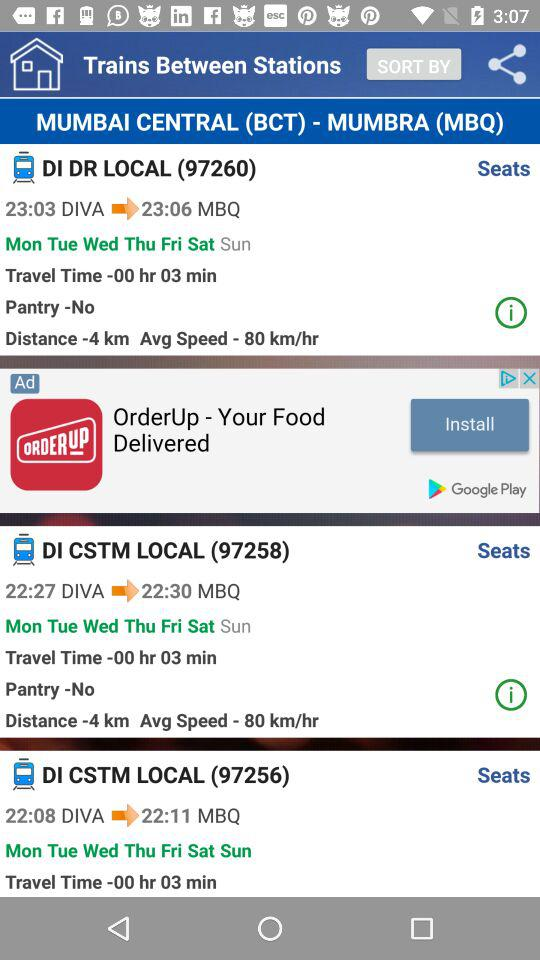How many trains are there?
Answer the question using a single word or phrase. 3 